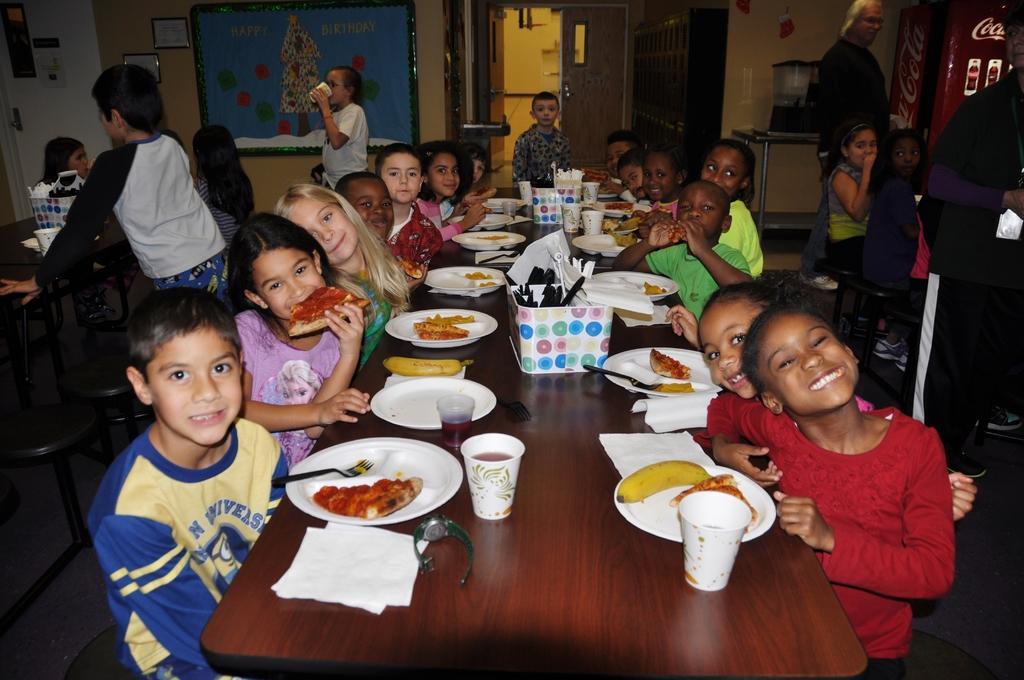Could you give a brief overview of what you see in this image? In this picture many people are seated around the dining table. In the center of the picture on the table there are many glasses, spoons, forks, plates and food items. There are many children in the room. On the top left there is a door. in the background on the wall there is a frame. In the top right there is a refrigerator. In the background there is another door and child standing. 